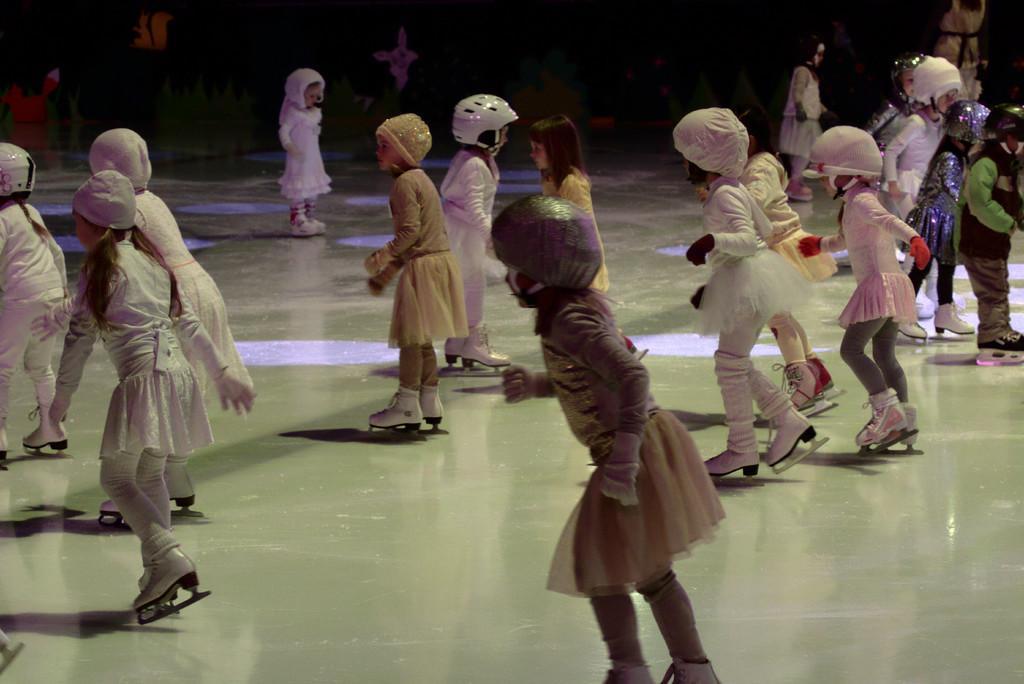Could you give a brief overview of what you see in this image? In this image, we can see a group of kids are skating on the floor. Few are wearing helmets and caps. Background we can see the dark view. 